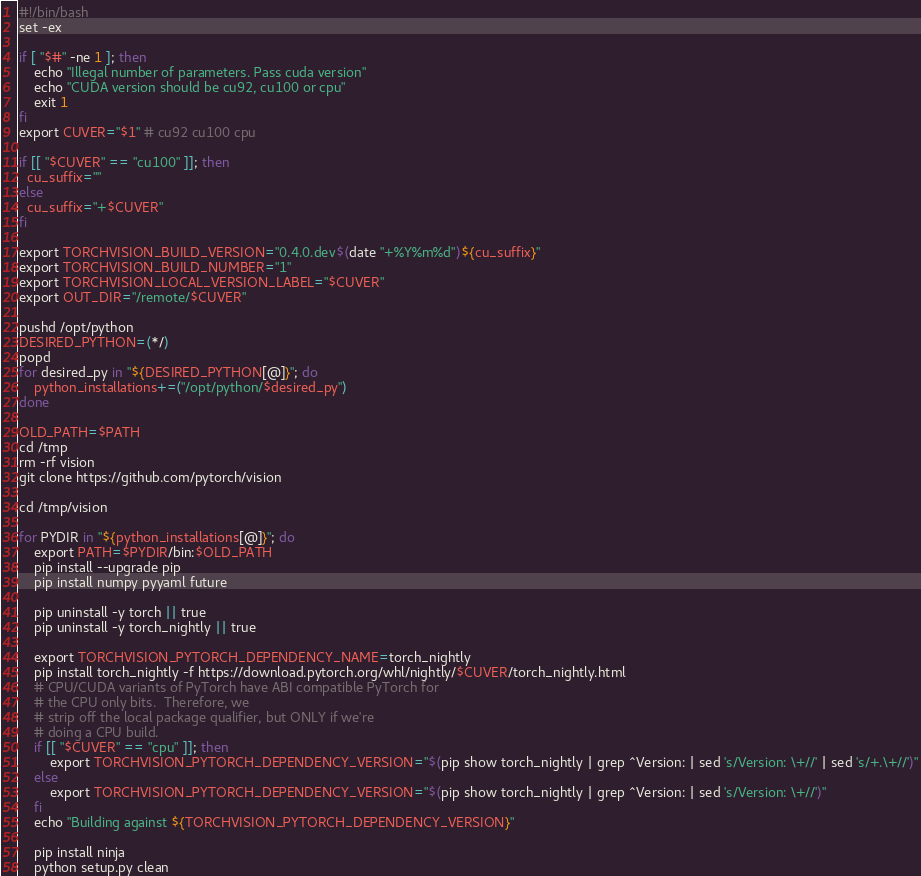<code> <loc_0><loc_0><loc_500><loc_500><_Bash_>#!/bin/bash
set -ex

if [ "$#" -ne 1 ]; then
    echo "Illegal number of parameters. Pass cuda version"
    echo "CUDA version should be cu92, cu100 or cpu"
    exit 1
fi
export CUVER="$1" # cu92 cu100 cpu

if [[ "$CUVER" == "cu100" ]]; then
  cu_suffix=""
else
  cu_suffix="+$CUVER"
fi

export TORCHVISION_BUILD_VERSION="0.4.0.dev$(date "+%Y%m%d")${cu_suffix}"
export TORCHVISION_BUILD_NUMBER="1"
export TORCHVISION_LOCAL_VERSION_LABEL="$CUVER"
export OUT_DIR="/remote/$CUVER"

pushd /opt/python
DESIRED_PYTHON=(*/)
popd
for desired_py in "${DESIRED_PYTHON[@]}"; do
    python_installations+=("/opt/python/$desired_py")
done

OLD_PATH=$PATH
cd /tmp
rm -rf vision
git clone https://github.com/pytorch/vision

cd /tmp/vision

for PYDIR in "${python_installations[@]}"; do
    export PATH=$PYDIR/bin:$OLD_PATH
    pip install --upgrade pip
    pip install numpy pyyaml future

    pip uninstall -y torch || true
    pip uninstall -y torch_nightly || true

    export TORCHVISION_PYTORCH_DEPENDENCY_NAME=torch_nightly
    pip install torch_nightly -f https://download.pytorch.org/whl/nightly/$CUVER/torch_nightly.html
    # CPU/CUDA variants of PyTorch have ABI compatible PyTorch for
    # the CPU only bits.  Therefore, we
    # strip off the local package qualifier, but ONLY if we're
    # doing a CPU build.
    if [[ "$CUVER" == "cpu" ]]; then
        export TORCHVISION_PYTORCH_DEPENDENCY_VERSION="$(pip show torch_nightly | grep ^Version: | sed 's/Version: \+//' | sed 's/+.\+//')"
    else
        export TORCHVISION_PYTORCH_DEPENDENCY_VERSION="$(pip show torch_nightly | grep ^Version: | sed 's/Version: \+//')"
    fi
    echo "Building against ${TORCHVISION_PYTORCH_DEPENDENCY_VERSION}"

    pip install ninja
    python setup.py clean</code> 